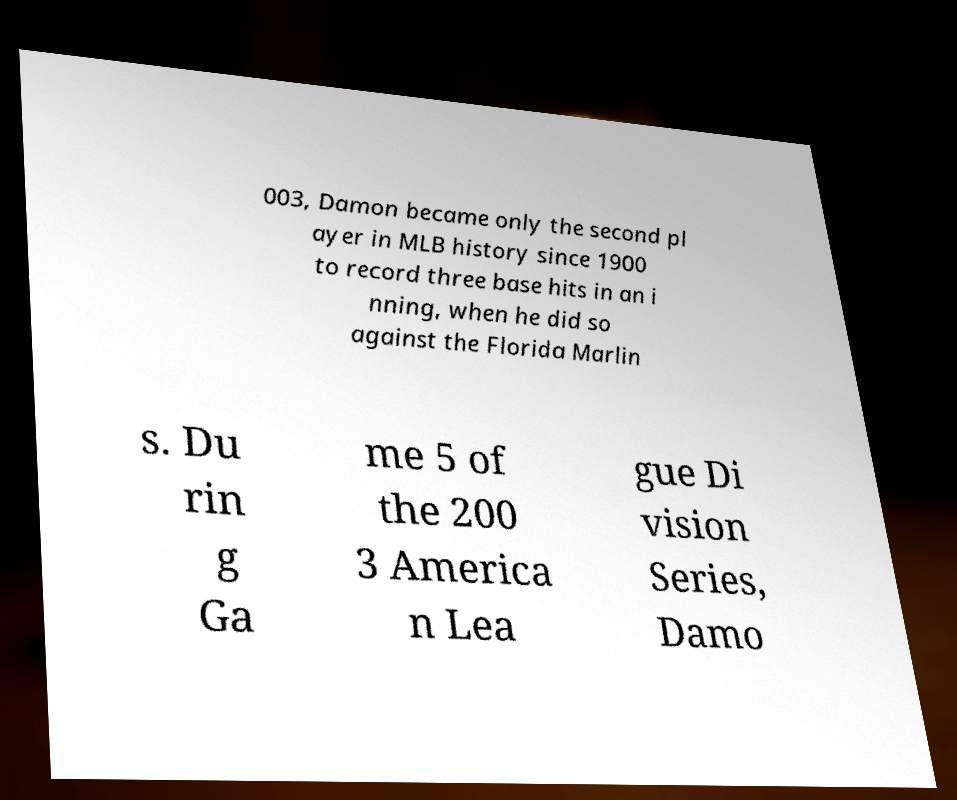Could you assist in decoding the text presented in this image and type it out clearly? 003, Damon became only the second pl ayer in MLB history since 1900 to record three base hits in an i nning, when he did so against the Florida Marlin s. Du rin g Ga me 5 of the 200 3 America n Lea gue Di vision Series, Damo 